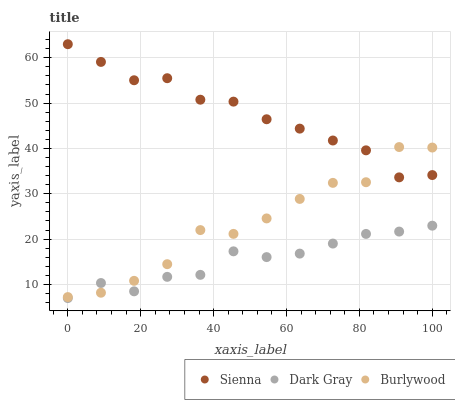Does Dark Gray have the minimum area under the curve?
Answer yes or no. Yes. Does Sienna have the maximum area under the curve?
Answer yes or no. Yes. Does Burlywood have the minimum area under the curve?
Answer yes or no. No. Does Burlywood have the maximum area under the curve?
Answer yes or no. No. Is Dark Gray the smoothest?
Answer yes or no. Yes. Is Burlywood the roughest?
Answer yes or no. Yes. Is Burlywood the smoothest?
Answer yes or no. No. Is Dark Gray the roughest?
Answer yes or no. No. Does Dark Gray have the lowest value?
Answer yes or no. Yes. Does Burlywood have the lowest value?
Answer yes or no. No. Does Sienna have the highest value?
Answer yes or no. Yes. Does Burlywood have the highest value?
Answer yes or no. No. Is Dark Gray less than Sienna?
Answer yes or no. Yes. Is Sienna greater than Dark Gray?
Answer yes or no. Yes. Does Sienna intersect Burlywood?
Answer yes or no. Yes. Is Sienna less than Burlywood?
Answer yes or no. No. Is Sienna greater than Burlywood?
Answer yes or no. No. Does Dark Gray intersect Sienna?
Answer yes or no. No. 